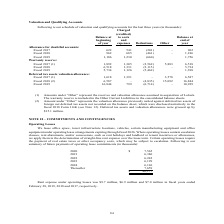According to Calamp's financial document, What do the amounts under "Other" represnet? the reserves and valuation allowance assumed in acquisition of LoJack.. The document states: "(1) Amounts under “Other” represent the reserves and valuation allowance assumed in acquisition of LoJack. The warranty reserve is included in the Oth..." Also, What was the warranty reserve balance at the beginning of fiscal year 2018? According to the financial document, 6,518 (in thousands). The relevant text states: "eserve: Fiscal 2017 (1) 1,892 1,305 (2,562) 5,883 6,518 Fiscal 2018 6,518 1,331 (2,115) - 5,734 Fiscal 2019 5,734 1,126 (5,462) 1,398 Deferred tax assets v..." Also, What was the allowance for doubtful accounts balance at the beginning of fiscal year 2019? According to the financial document, 1,186 (in thousands). The relevant text states: "7 622 541 (201) - 962 Fiscal 2018 962 685 (461) - 1,186 Fiscal 2019 1,186 1,230 (660) 1,756 Warranty reserve: Fiscal 2017 (1) 1,892 1,305 (2,562) 5,883 6,5..." Also, can you calculate: What was the difference in the balance at the end of the year compared to the start of the year for warranty reserve in fiscal year 2017? Based on the calculation: (6,518-1,892), the result is 4626 (in thousands). This is based on the information: "230 (660) 1,756 Warranty reserve: Fiscal 2017 (1) 1,892 1,305 (2,562) 5,883 6,518 Fiscal 2018 6,518 1,331 (2,115) - 5,734 Fiscal 2019 5,734 1,126 (5,462) 1 eserve: Fiscal 2017 (1) 1,892 1,305 (2,562) ..." The key data points involved are: 1,892, 6,518. Also, can you calculate: What was the change in the balance at the beginning of the year for allowance for doubtful accounts between fiscal year 2018 and 2019? Based on the calculation: (1,186-962), the result is 224 (in thousands). This is based on the information: "or doubtful accounts: Fiscal 2017 622 541 (201) - 962 Fiscal 2018 962 685 (461) - 1,186 Fiscal 2019 1,186 1,230 (660) 1,756 Warranty reserve: Fiscal 2017 7 622 541 (201) - 962 Fiscal 2018 962 685 (461..." The key data points involved are: 1,186, 962. Also, can you calculate: What was the change in Other from Deferred tax assets valuation allowance between Fiscal 2017 and 2018? Based on the calculation: (15,092-3,578), the result is 11514 (in thousands). This is based on the information: "391 - 3,578 6,587 Fiscal 2018 (2) 6,587 - (4,835) 15,092 16,844 Fiscal 2019 16,844 799 (6,714) - 10,929 aluation allowance: Fiscal 2017 (1) 1,618 1,391 - 3,578 6,587 Fiscal 2018 (2) 6,587 - (4,835) 15..." The key data points involved are: 15,092, 3,578. 